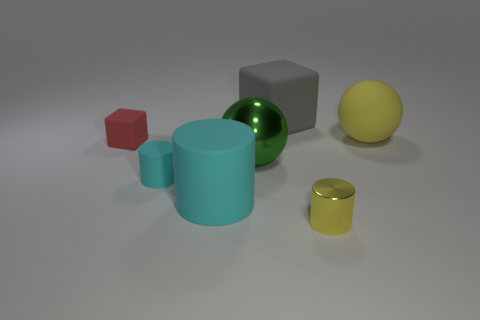Are there fewer yellow cylinders than tiny gray balls?
Ensure brevity in your answer.  No. How many cubes are green things or tiny shiny objects?
Keep it short and to the point. 0. What number of objects have the same color as the small shiny cylinder?
Provide a short and direct response. 1. There is a object that is behind the green shiny sphere and on the left side of the metallic ball; what is its size?
Keep it short and to the point. Small. Are there fewer cyan matte cylinders that are right of the large matte cylinder than large green matte spheres?
Your response must be concise. No. Does the small cube have the same material as the small yellow thing?
Provide a short and direct response. No. How many things are either big gray rubber things or large yellow matte balls?
Keep it short and to the point. 2. How many small yellow cylinders are made of the same material as the large cyan thing?
Offer a terse response. 0. There is a metallic thing that is the same shape as the large yellow rubber object; what size is it?
Give a very brief answer. Large. Are there any tiny cyan cylinders in front of the large green thing?
Offer a terse response. Yes. 